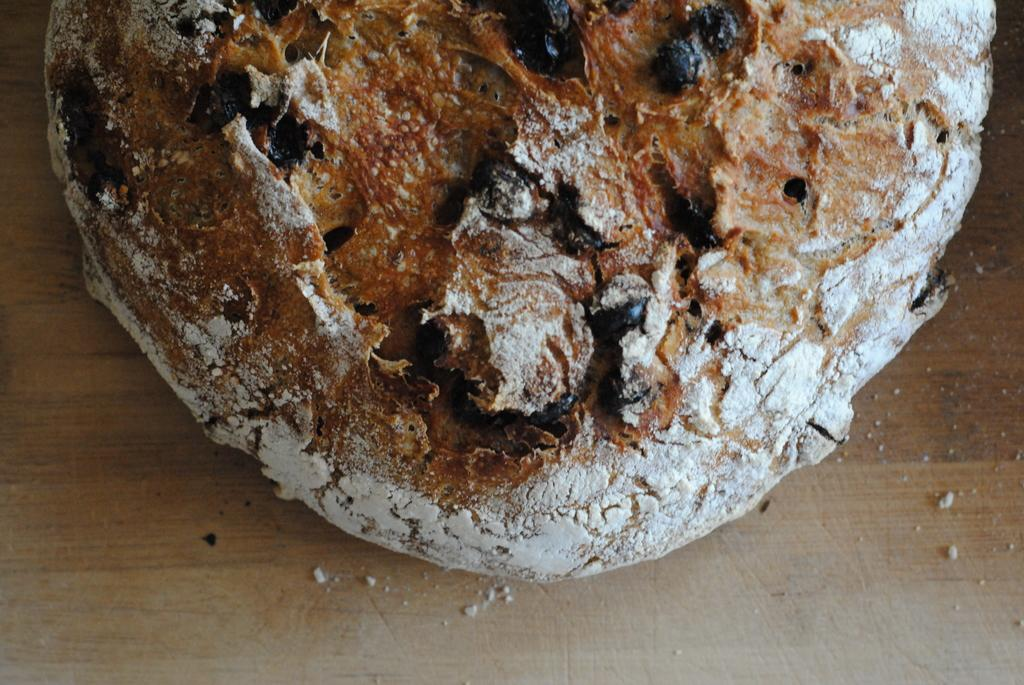What type of items can be seen in the image? There are food items in the image. On what surface are the food items placed? The food items are placed on a wooden surface. What type of wool is used to make the tablecloth in the image? There is no tablecloth present in the image, and therefore no wool can be identified. 